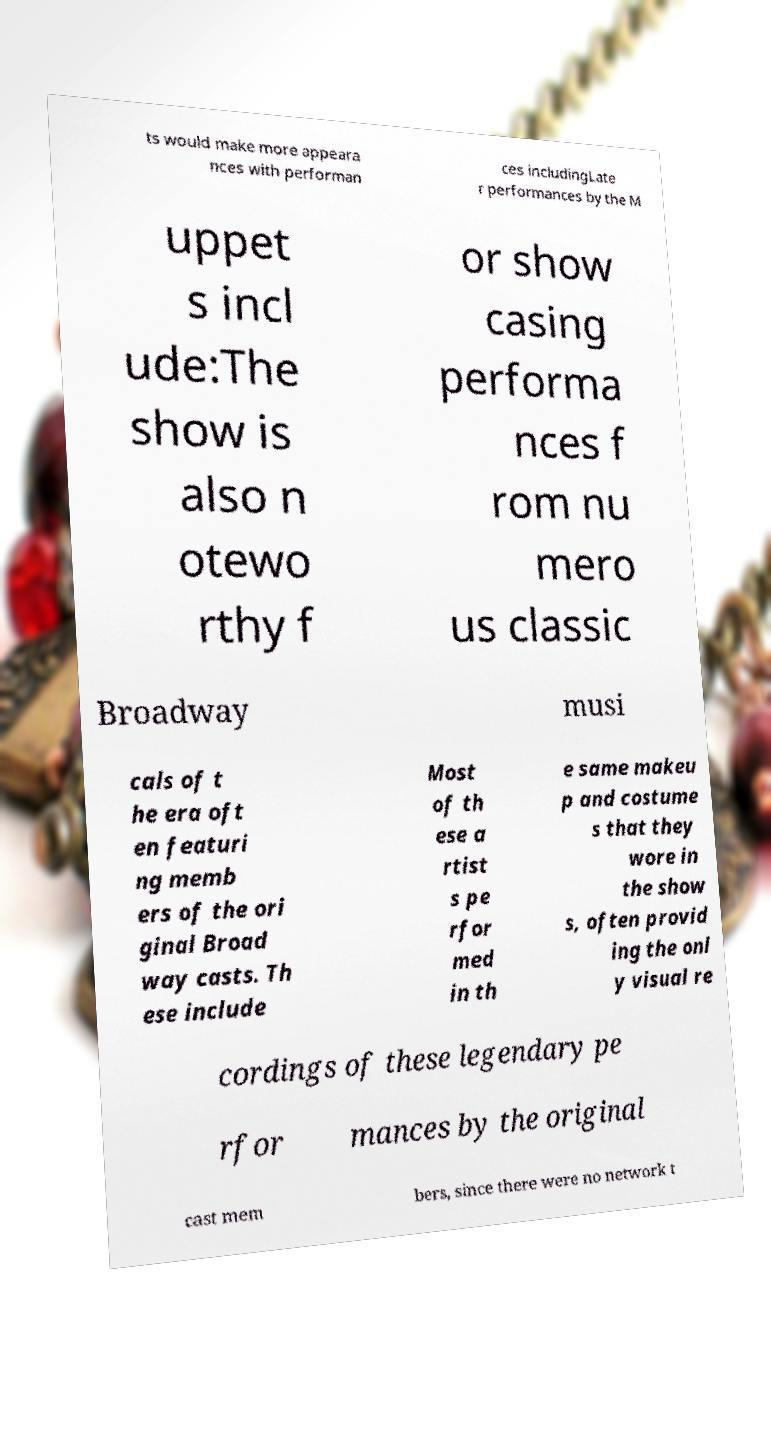Could you extract and type out the text from this image? ts would make more appeara nces with performan ces includingLate r performances by the M uppet s incl ude:The show is also n otewo rthy f or show casing performa nces f rom nu mero us classic Broadway musi cals of t he era oft en featuri ng memb ers of the ori ginal Broad way casts. Th ese include Most of th ese a rtist s pe rfor med in th e same makeu p and costume s that they wore in the show s, often provid ing the onl y visual re cordings of these legendary pe rfor mances by the original cast mem bers, since there were no network t 